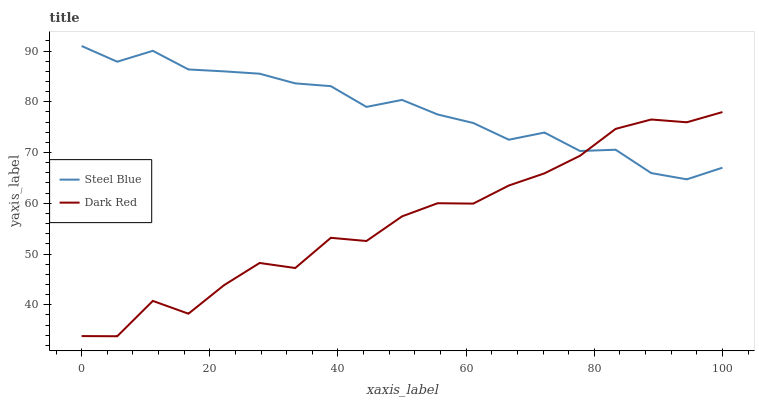Does Dark Red have the minimum area under the curve?
Answer yes or no. Yes. Does Steel Blue have the maximum area under the curve?
Answer yes or no. Yes. Does Steel Blue have the minimum area under the curve?
Answer yes or no. No. Is Steel Blue the smoothest?
Answer yes or no. Yes. Is Dark Red the roughest?
Answer yes or no. Yes. Is Steel Blue the roughest?
Answer yes or no. No. Does Dark Red have the lowest value?
Answer yes or no. Yes. Does Steel Blue have the lowest value?
Answer yes or no. No. Does Steel Blue have the highest value?
Answer yes or no. Yes. Does Steel Blue intersect Dark Red?
Answer yes or no. Yes. Is Steel Blue less than Dark Red?
Answer yes or no. No. Is Steel Blue greater than Dark Red?
Answer yes or no. No. 